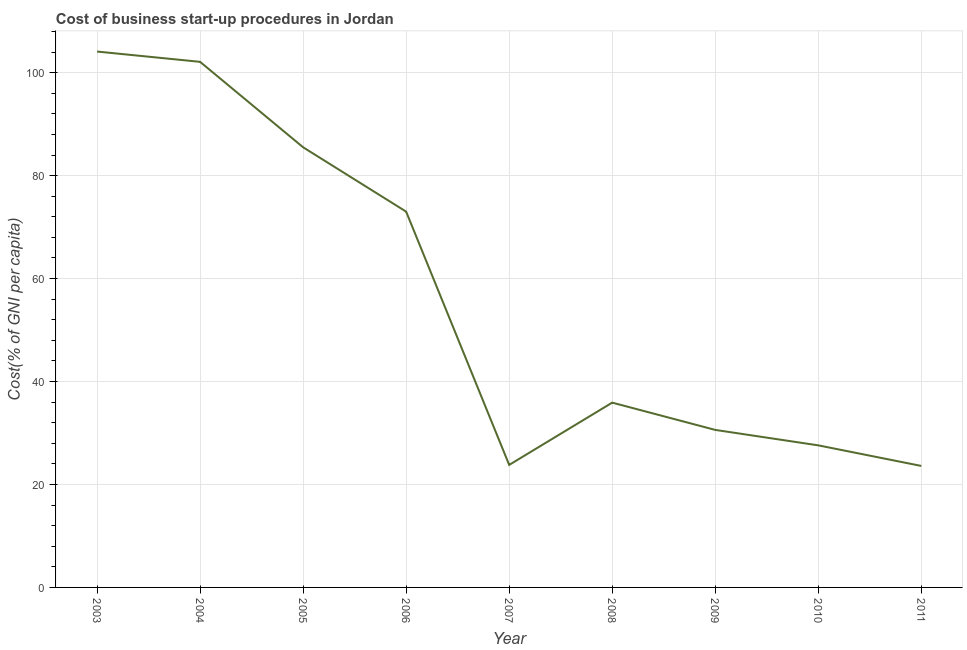What is the cost of business startup procedures in 2011?
Your answer should be compact. 23.6. Across all years, what is the maximum cost of business startup procedures?
Keep it short and to the point. 104.1. Across all years, what is the minimum cost of business startup procedures?
Ensure brevity in your answer.  23.6. In which year was the cost of business startup procedures maximum?
Keep it short and to the point. 2003. What is the sum of the cost of business startup procedures?
Provide a succinct answer. 506.2. What is the difference between the cost of business startup procedures in 2007 and 2008?
Provide a short and direct response. -12.1. What is the average cost of business startup procedures per year?
Keep it short and to the point. 56.24. What is the median cost of business startup procedures?
Make the answer very short. 35.9. Do a majority of the years between 2006 and 2008 (inclusive) have cost of business startup procedures greater than 80 %?
Offer a very short reply. No. What is the ratio of the cost of business startup procedures in 2008 to that in 2010?
Provide a succinct answer. 1.3. Is the difference between the cost of business startup procedures in 2007 and 2009 greater than the difference between any two years?
Provide a short and direct response. No. What is the difference between the highest and the lowest cost of business startup procedures?
Provide a succinct answer. 80.5. Does the cost of business startup procedures monotonically increase over the years?
Provide a short and direct response. No. How many lines are there?
Offer a terse response. 1. What is the difference between two consecutive major ticks on the Y-axis?
Provide a short and direct response. 20. What is the title of the graph?
Give a very brief answer. Cost of business start-up procedures in Jordan. What is the label or title of the Y-axis?
Offer a terse response. Cost(% of GNI per capita). What is the Cost(% of GNI per capita) of 2003?
Give a very brief answer. 104.1. What is the Cost(% of GNI per capita) in 2004?
Make the answer very short. 102.1. What is the Cost(% of GNI per capita) of 2005?
Provide a short and direct response. 85.5. What is the Cost(% of GNI per capita) in 2007?
Make the answer very short. 23.8. What is the Cost(% of GNI per capita) of 2008?
Keep it short and to the point. 35.9. What is the Cost(% of GNI per capita) in 2009?
Your answer should be compact. 30.6. What is the Cost(% of GNI per capita) of 2010?
Your response must be concise. 27.6. What is the Cost(% of GNI per capita) of 2011?
Your answer should be very brief. 23.6. What is the difference between the Cost(% of GNI per capita) in 2003 and 2005?
Your answer should be compact. 18.6. What is the difference between the Cost(% of GNI per capita) in 2003 and 2006?
Offer a very short reply. 31.1. What is the difference between the Cost(% of GNI per capita) in 2003 and 2007?
Your answer should be very brief. 80.3. What is the difference between the Cost(% of GNI per capita) in 2003 and 2008?
Make the answer very short. 68.2. What is the difference between the Cost(% of GNI per capita) in 2003 and 2009?
Your response must be concise. 73.5. What is the difference between the Cost(% of GNI per capita) in 2003 and 2010?
Your response must be concise. 76.5. What is the difference between the Cost(% of GNI per capita) in 2003 and 2011?
Offer a very short reply. 80.5. What is the difference between the Cost(% of GNI per capita) in 2004 and 2006?
Offer a very short reply. 29.1. What is the difference between the Cost(% of GNI per capita) in 2004 and 2007?
Offer a terse response. 78.3. What is the difference between the Cost(% of GNI per capita) in 2004 and 2008?
Provide a short and direct response. 66.2. What is the difference between the Cost(% of GNI per capita) in 2004 and 2009?
Your answer should be compact. 71.5. What is the difference between the Cost(% of GNI per capita) in 2004 and 2010?
Offer a very short reply. 74.5. What is the difference between the Cost(% of GNI per capita) in 2004 and 2011?
Give a very brief answer. 78.5. What is the difference between the Cost(% of GNI per capita) in 2005 and 2007?
Keep it short and to the point. 61.7. What is the difference between the Cost(% of GNI per capita) in 2005 and 2008?
Offer a terse response. 49.6. What is the difference between the Cost(% of GNI per capita) in 2005 and 2009?
Ensure brevity in your answer.  54.9. What is the difference between the Cost(% of GNI per capita) in 2005 and 2010?
Provide a succinct answer. 57.9. What is the difference between the Cost(% of GNI per capita) in 2005 and 2011?
Provide a short and direct response. 61.9. What is the difference between the Cost(% of GNI per capita) in 2006 and 2007?
Offer a terse response. 49.2. What is the difference between the Cost(% of GNI per capita) in 2006 and 2008?
Keep it short and to the point. 37.1. What is the difference between the Cost(% of GNI per capita) in 2006 and 2009?
Make the answer very short. 42.4. What is the difference between the Cost(% of GNI per capita) in 2006 and 2010?
Make the answer very short. 45.4. What is the difference between the Cost(% of GNI per capita) in 2006 and 2011?
Offer a terse response. 49.4. What is the difference between the Cost(% of GNI per capita) in 2007 and 2010?
Ensure brevity in your answer.  -3.8. What is the difference between the Cost(% of GNI per capita) in 2008 and 2010?
Offer a very short reply. 8.3. What is the difference between the Cost(% of GNI per capita) in 2009 and 2011?
Give a very brief answer. 7. What is the ratio of the Cost(% of GNI per capita) in 2003 to that in 2005?
Offer a very short reply. 1.22. What is the ratio of the Cost(% of GNI per capita) in 2003 to that in 2006?
Ensure brevity in your answer.  1.43. What is the ratio of the Cost(% of GNI per capita) in 2003 to that in 2007?
Keep it short and to the point. 4.37. What is the ratio of the Cost(% of GNI per capita) in 2003 to that in 2009?
Your answer should be very brief. 3.4. What is the ratio of the Cost(% of GNI per capita) in 2003 to that in 2010?
Provide a short and direct response. 3.77. What is the ratio of the Cost(% of GNI per capita) in 2003 to that in 2011?
Your answer should be compact. 4.41. What is the ratio of the Cost(% of GNI per capita) in 2004 to that in 2005?
Provide a succinct answer. 1.19. What is the ratio of the Cost(% of GNI per capita) in 2004 to that in 2006?
Offer a very short reply. 1.4. What is the ratio of the Cost(% of GNI per capita) in 2004 to that in 2007?
Offer a very short reply. 4.29. What is the ratio of the Cost(% of GNI per capita) in 2004 to that in 2008?
Keep it short and to the point. 2.84. What is the ratio of the Cost(% of GNI per capita) in 2004 to that in 2009?
Provide a succinct answer. 3.34. What is the ratio of the Cost(% of GNI per capita) in 2004 to that in 2010?
Your answer should be very brief. 3.7. What is the ratio of the Cost(% of GNI per capita) in 2004 to that in 2011?
Make the answer very short. 4.33. What is the ratio of the Cost(% of GNI per capita) in 2005 to that in 2006?
Keep it short and to the point. 1.17. What is the ratio of the Cost(% of GNI per capita) in 2005 to that in 2007?
Ensure brevity in your answer.  3.59. What is the ratio of the Cost(% of GNI per capita) in 2005 to that in 2008?
Offer a terse response. 2.38. What is the ratio of the Cost(% of GNI per capita) in 2005 to that in 2009?
Ensure brevity in your answer.  2.79. What is the ratio of the Cost(% of GNI per capita) in 2005 to that in 2010?
Make the answer very short. 3.1. What is the ratio of the Cost(% of GNI per capita) in 2005 to that in 2011?
Your answer should be compact. 3.62. What is the ratio of the Cost(% of GNI per capita) in 2006 to that in 2007?
Your response must be concise. 3.07. What is the ratio of the Cost(% of GNI per capita) in 2006 to that in 2008?
Give a very brief answer. 2.03. What is the ratio of the Cost(% of GNI per capita) in 2006 to that in 2009?
Give a very brief answer. 2.39. What is the ratio of the Cost(% of GNI per capita) in 2006 to that in 2010?
Provide a short and direct response. 2.65. What is the ratio of the Cost(% of GNI per capita) in 2006 to that in 2011?
Ensure brevity in your answer.  3.09. What is the ratio of the Cost(% of GNI per capita) in 2007 to that in 2008?
Offer a terse response. 0.66. What is the ratio of the Cost(% of GNI per capita) in 2007 to that in 2009?
Offer a terse response. 0.78. What is the ratio of the Cost(% of GNI per capita) in 2007 to that in 2010?
Provide a short and direct response. 0.86. What is the ratio of the Cost(% of GNI per capita) in 2008 to that in 2009?
Provide a succinct answer. 1.17. What is the ratio of the Cost(% of GNI per capita) in 2008 to that in 2010?
Keep it short and to the point. 1.3. What is the ratio of the Cost(% of GNI per capita) in 2008 to that in 2011?
Make the answer very short. 1.52. What is the ratio of the Cost(% of GNI per capita) in 2009 to that in 2010?
Ensure brevity in your answer.  1.11. What is the ratio of the Cost(% of GNI per capita) in 2009 to that in 2011?
Offer a terse response. 1.3. What is the ratio of the Cost(% of GNI per capita) in 2010 to that in 2011?
Offer a very short reply. 1.17. 